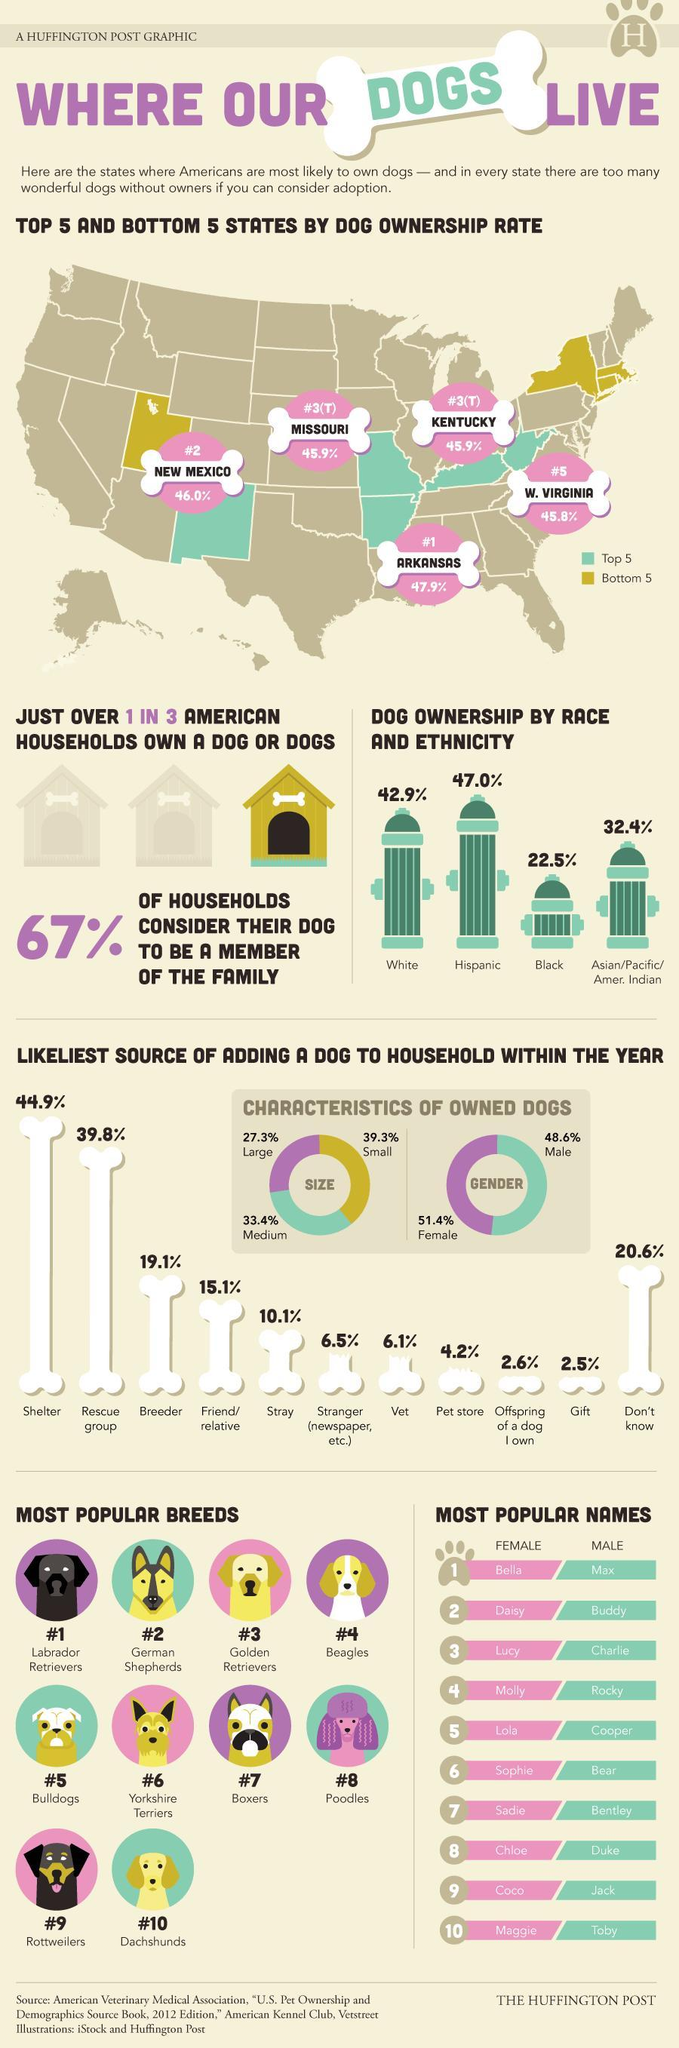Which American state is home for least number of dogs?
Answer the question with a short phrase. W. VIRGINIA Which is the third most popular dog breed across America? Golden Retrievers Which is the least popular female dog name in America? Maggie Which is the second most popular dog breed across America? German Shepherds Which race and ethnicity owns least number of dogs in America? Black Which is the most popular dog breed across America? Labrador Retrievers Which is the least popular dog breed across America? Dachshunds Which American state is home for most number of dogs? ARKANSAS Which race and ethnicity owns more dogs in America? Hispanic Which is the second least popular dog breed across America? Rottweilers 